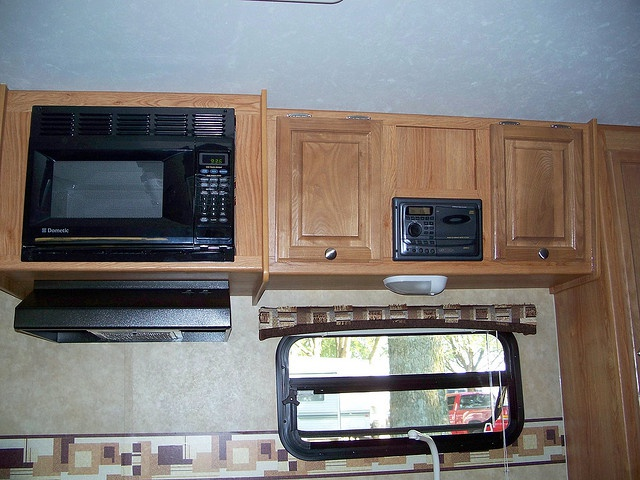Describe the objects in this image and their specific colors. I can see microwave in gray, black, and blue tones and truck in gray, lightpink, lightgray, and darkgray tones in this image. 